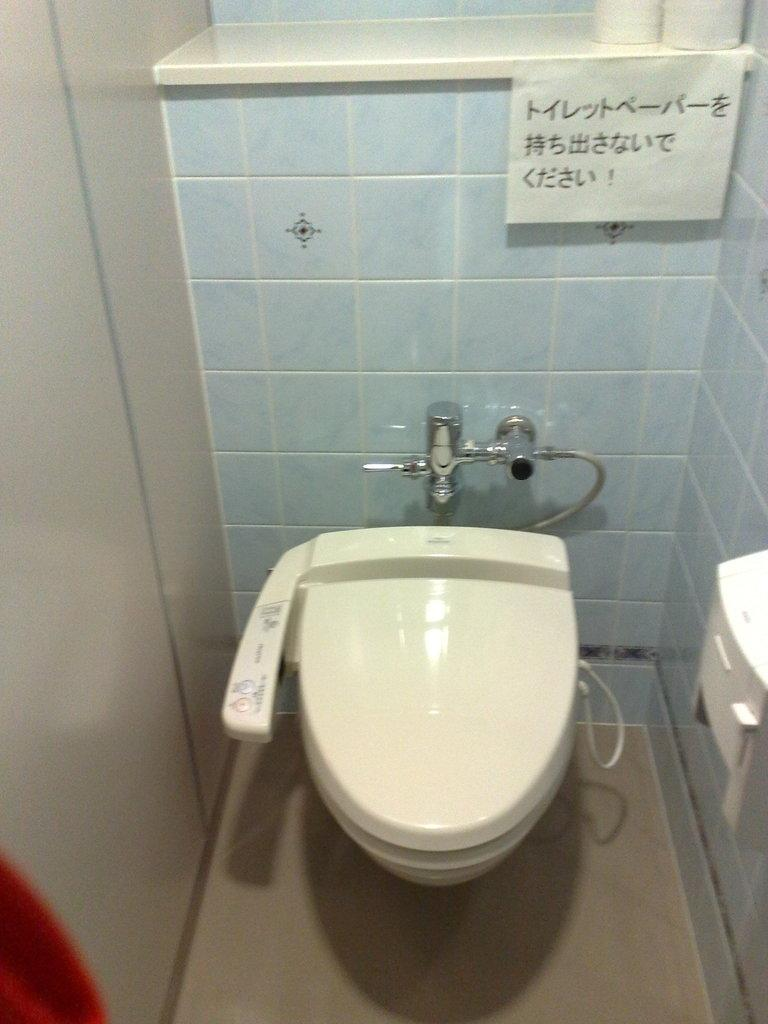What is the main object in the image? There is a toilet seat in the image. What is the paper in the image used for? The paper in the image is likely used for wiping. What type of material are the paper rolls made of? The paper rolls are made of paper. What type of flooring is visible in the image? There are tiles in the image. What is the unidentified object in the image? There is an object in the image, but its purpose or identity is not clear. How does the toilet seat contribute to the tax revenue in the image? The toilet seat does not contribute to tax revenue in the image; it is an inanimate object. What type of sail is visible on the toilet seat in the image? There is no sail present in the image, as it is a toilet seat and not a sailboat. 